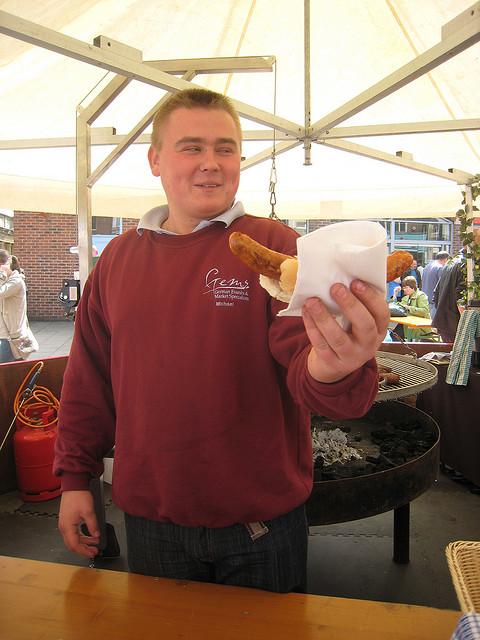Is the man holding something a vegan would eat?
Give a very brief answer. No. Does the hotdog fit the bun?
Answer briefly. No. What kind of grill is behind the man?
Quick response, please. Charcoal. 